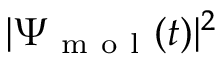Convert formula to latex. <formula><loc_0><loc_0><loc_500><loc_500>| \Psi _ { m o l } ( t ) | ^ { 2 }</formula> 